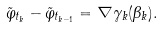<formula> <loc_0><loc_0><loc_500><loc_500>\tilde { \varphi } _ { t _ { k } } - \tilde { \varphi } _ { t _ { k - 1 } } = \nabla \gamma _ { k } ( \beta _ { k } ) .</formula> 